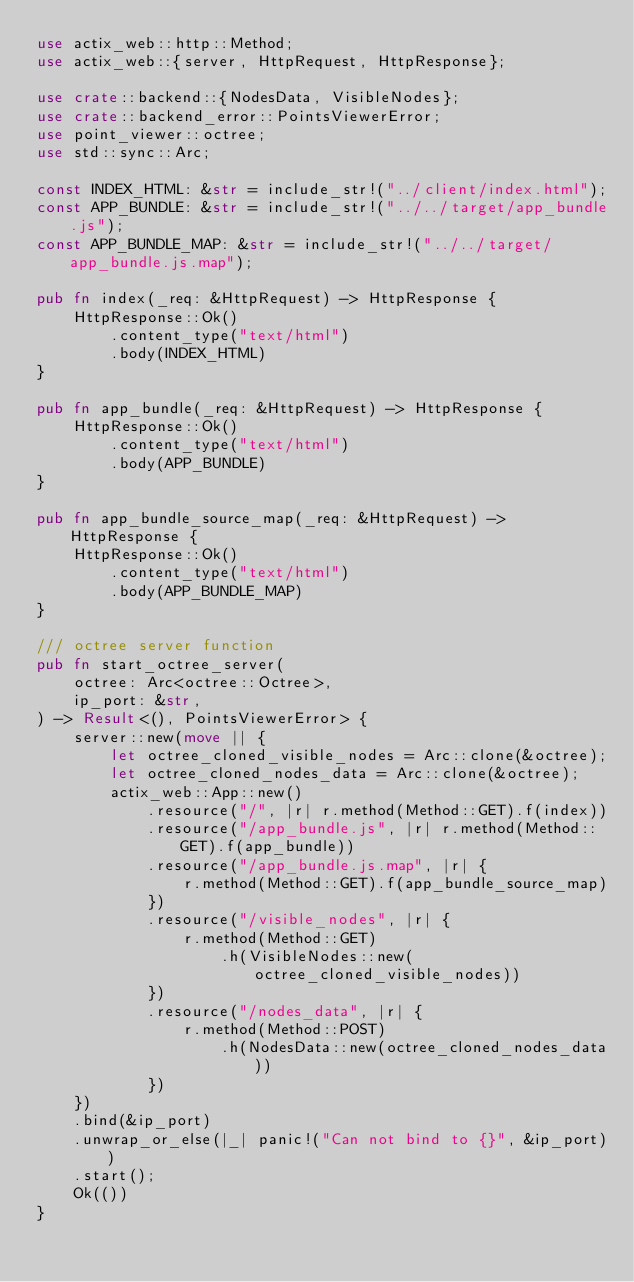Convert code to text. <code><loc_0><loc_0><loc_500><loc_500><_Rust_>use actix_web::http::Method;
use actix_web::{server, HttpRequest, HttpResponse};

use crate::backend::{NodesData, VisibleNodes};
use crate::backend_error::PointsViewerError;
use point_viewer::octree;
use std::sync::Arc;

const INDEX_HTML: &str = include_str!("../client/index.html");
const APP_BUNDLE: &str = include_str!("../../target/app_bundle.js");
const APP_BUNDLE_MAP: &str = include_str!("../../target/app_bundle.js.map");

pub fn index(_req: &HttpRequest) -> HttpResponse {
    HttpResponse::Ok()
        .content_type("text/html")
        .body(INDEX_HTML)
}

pub fn app_bundle(_req: &HttpRequest) -> HttpResponse {
    HttpResponse::Ok()
        .content_type("text/html")
        .body(APP_BUNDLE)
}

pub fn app_bundle_source_map(_req: &HttpRequest) -> HttpResponse {
    HttpResponse::Ok()
        .content_type("text/html")
        .body(APP_BUNDLE_MAP)
}

/// octree server function
pub fn start_octree_server(
    octree: Arc<octree::Octree>,
    ip_port: &str,
) -> Result<(), PointsViewerError> {
    server::new(move || {
        let octree_cloned_visible_nodes = Arc::clone(&octree);
        let octree_cloned_nodes_data = Arc::clone(&octree);
        actix_web::App::new()
            .resource("/", |r| r.method(Method::GET).f(index))
            .resource("/app_bundle.js", |r| r.method(Method::GET).f(app_bundle))
            .resource("/app_bundle.js.map", |r| {
                r.method(Method::GET).f(app_bundle_source_map)
            })
            .resource("/visible_nodes", |r| {
                r.method(Method::GET)
                    .h(VisibleNodes::new(octree_cloned_visible_nodes))
            })
            .resource("/nodes_data", |r| {
                r.method(Method::POST)
                    .h(NodesData::new(octree_cloned_nodes_data))
            })
    })
    .bind(&ip_port)
    .unwrap_or_else(|_| panic!("Can not bind to {}", &ip_port))
    .start();
    Ok(())
}
</code> 